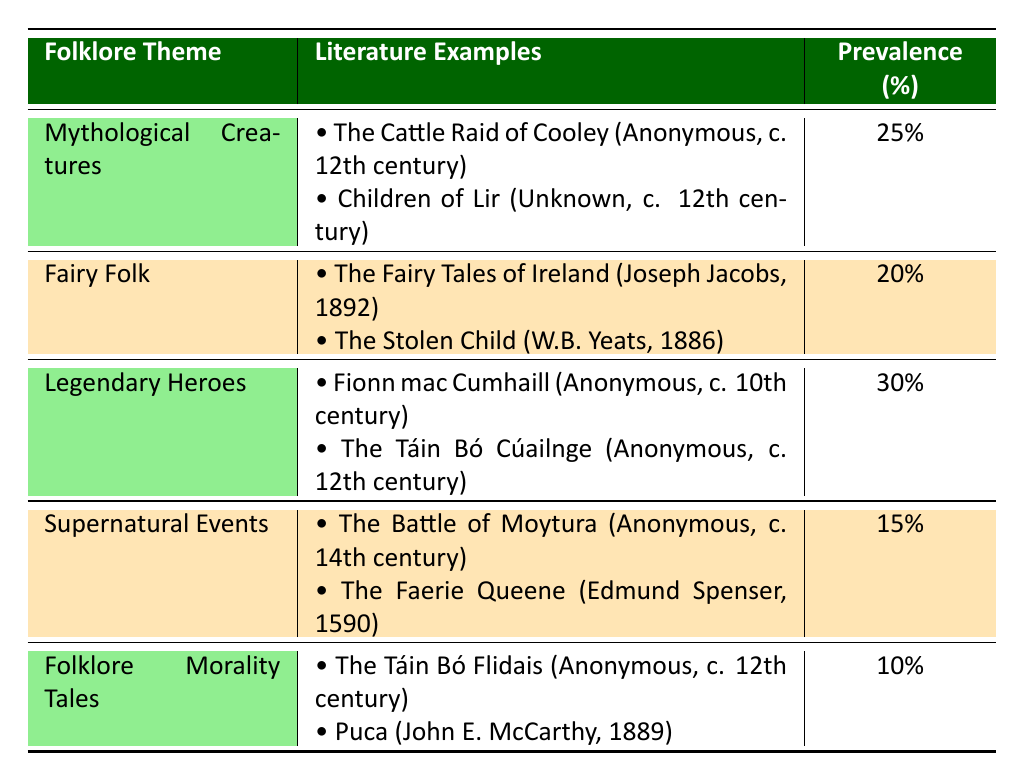What is the most prevalent theme in the table? By examining the prevalence percentages in the table, "Legendary Heroes" has the highest percentage at 30%.
Answer: 30% How many themes have a prevalence percentage greater than 20%? From the table, "Mythological Creatures" (25%) and "Legendary Heroes" (30%) are the only themes with a percentage greater than 20%, totaling two themes.
Answer: 2 Is there an example of a literature work about "Fairy Folk" published before 1900? Yes, "The Stolen Child" by W.B. Yeats was published in 1886, which is before 1900.
Answer: Yes What is the average prevalence percentage of all themes listed? To calculate the average, add all prevalence percentages: 25 + 20 + 30 + 15 + 10 = 100, and then divide by the number of themes (5). Therefore, the average is 100 / 5 = 20%.
Answer: 20% Are there any themes that include literature examples published in the 12th century? Yes, both "Mythological Creatures" and "Legendary Heroes" include literature examples published in the 12th century.
Answer: Yes Which theme has the lowest prevalence percentage and what is it? The table shows that "Folklore Morality Tales" has the lowest prevalence percentage at 10%.
Answer: 10% What percentage of literature examples listed are about "Supernatural Events"? There are two examples under "Supernatural Events," and since there are a total of ten examples across all themes, the percentage is (2/10) * 100 = 20%.
Answer: 20% Is "The Cattle Raid of Cooley" an example of a theme related to Legendary Heroes? No, "The Cattle Raid of Cooley" is categorized under "Mythological Creatures".
Answer: No How many literature examples are there in total across all themes? There are 2 examples for each of the 5 themes, so the total number of literature examples is 2 * 5 = 10.
Answer: 10 